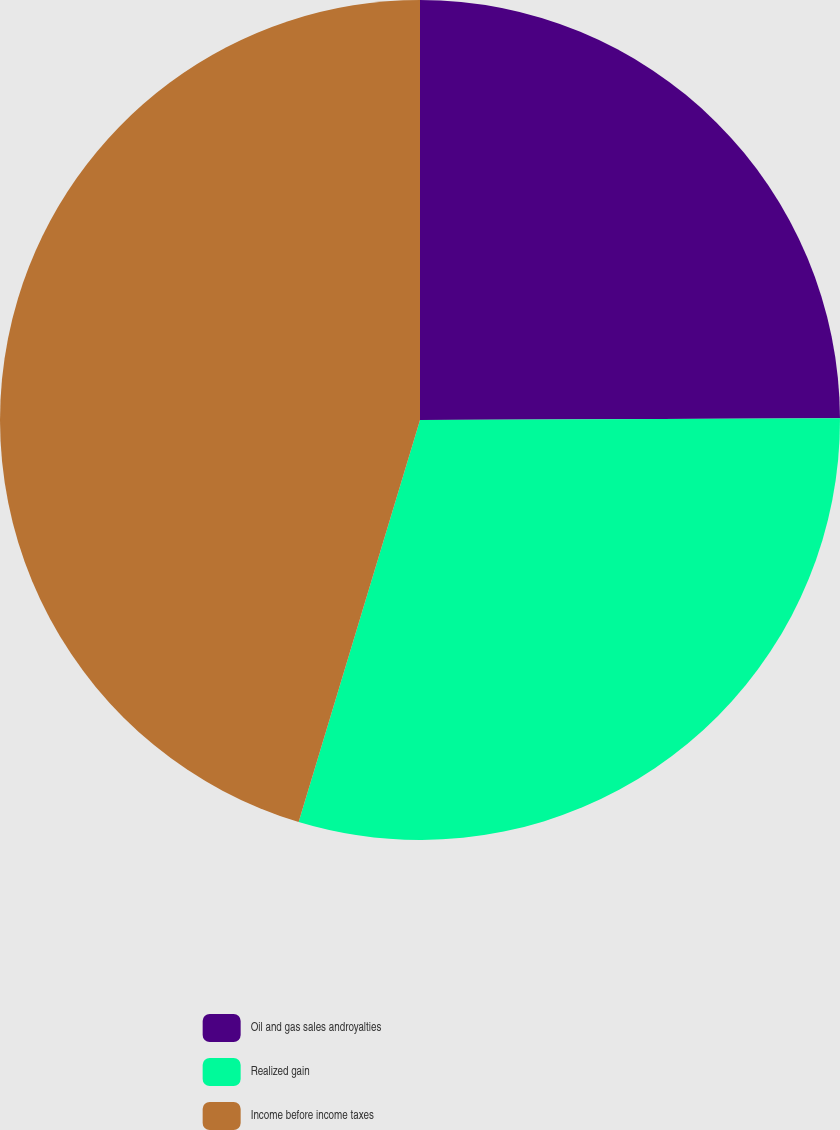<chart> <loc_0><loc_0><loc_500><loc_500><pie_chart><fcel>Oil and gas sales androyalties<fcel>Realized gain<fcel>Income before income taxes<nl><fcel>24.93%<fcel>29.73%<fcel>45.33%<nl></chart> 